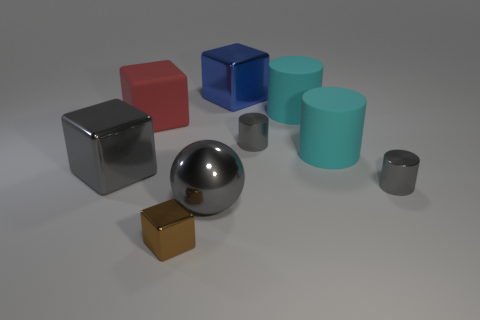How many cubes are large blue things or brown things?
Give a very brief answer. 2. What is the shape of the small brown object that is in front of the large thing in front of the tiny gray cylinder in front of the big gray metallic block?
Keep it short and to the point. Cube. There is a big thing that is the same color as the sphere; what shape is it?
Make the answer very short. Cube. How many shiny cylinders are the same size as the gray cube?
Keep it short and to the point. 0. There is a tiny cylinder that is behind the large gray block; are there any large blue metallic objects that are in front of it?
Keep it short and to the point. No. How many objects are either tiny brown cubes or purple cylinders?
Your answer should be compact. 1. There is a large shiny cube that is on the right side of the gray metal sphere right of the rubber object that is on the left side of the ball; what is its color?
Keep it short and to the point. Blue. Are there any other things of the same color as the big matte cube?
Make the answer very short. No. Is the size of the brown metallic object the same as the gray metal block?
Your response must be concise. No. How many objects are either large gray metallic objects that are right of the tiny brown shiny thing or tiny metal things left of the big sphere?
Make the answer very short. 2. 